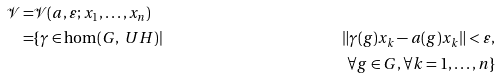<formula> <loc_0><loc_0><loc_500><loc_500>\mathcal { V } = & \mathcal { V } ( a , \varepsilon ; x _ { 1 } , \dots , x _ { n } ) \\ = & \{ \gamma \in \hom ( G , \ U H ) | & \| \gamma ( g ) x _ { k } - a ( g ) x _ { k } \| < \varepsilon , \\ & & \forall g \in G , \forall k = 1 , \dots , n \}</formula> 